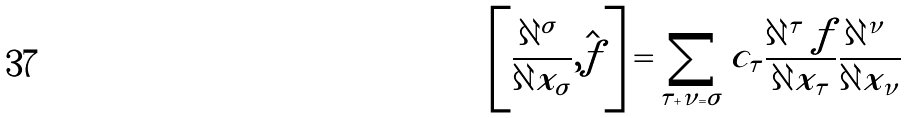Convert formula to latex. <formula><loc_0><loc_0><loc_500><loc_500>\left [ \frac { \partial ^ { | \sigma | } } { \partial { x _ { \sigma } } } , \hat { f } \right ] = \sum _ { \tau + \nu = \sigma } c _ { \tau } \frac { \partial ^ { | \tau | } { f } } { \partial { x _ { \tau } } } \frac { \partial ^ { | \nu | } } { \partial { x _ { \nu } } }</formula> 